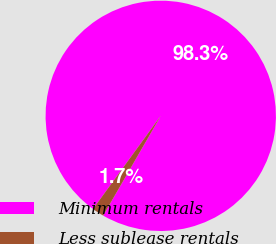Convert chart to OTSL. <chart><loc_0><loc_0><loc_500><loc_500><pie_chart><fcel>Minimum rentals<fcel>Less sublease rentals<nl><fcel>98.32%<fcel>1.68%<nl></chart> 